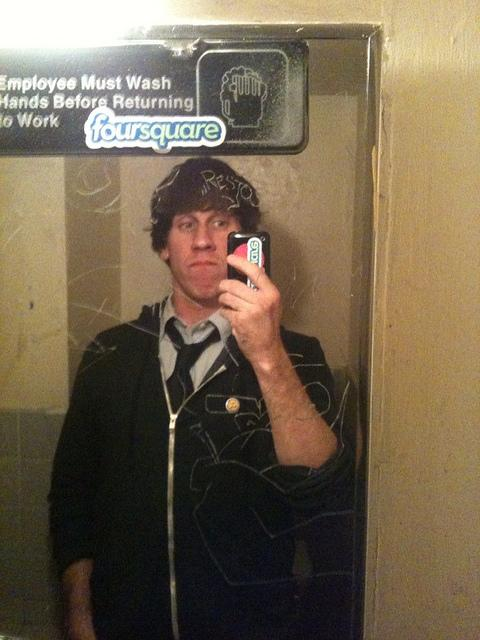Who is taking this man's picture? Please explain your reasoning. he is. The man takes a selfie. 